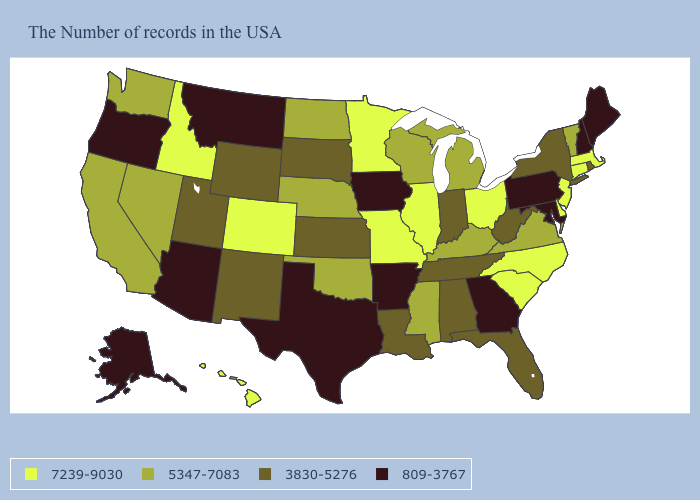What is the value of New Mexico?
Give a very brief answer. 3830-5276. Name the states that have a value in the range 809-3767?
Quick response, please. Maine, New Hampshire, Maryland, Pennsylvania, Georgia, Arkansas, Iowa, Texas, Montana, Arizona, Oregon, Alaska. Name the states that have a value in the range 809-3767?
Answer briefly. Maine, New Hampshire, Maryland, Pennsylvania, Georgia, Arkansas, Iowa, Texas, Montana, Arizona, Oregon, Alaska. Which states hav the highest value in the West?
Quick response, please. Colorado, Idaho, Hawaii. Which states have the lowest value in the USA?
Quick response, please. Maine, New Hampshire, Maryland, Pennsylvania, Georgia, Arkansas, Iowa, Texas, Montana, Arizona, Oregon, Alaska. Name the states that have a value in the range 809-3767?
Short answer required. Maine, New Hampshire, Maryland, Pennsylvania, Georgia, Arkansas, Iowa, Texas, Montana, Arizona, Oregon, Alaska. What is the lowest value in the MidWest?
Concise answer only. 809-3767. Among the states that border Iowa , does Missouri have the highest value?
Write a very short answer. Yes. Which states have the lowest value in the West?
Be succinct. Montana, Arizona, Oregon, Alaska. Name the states that have a value in the range 3830-5276?
Short answer required. Rhode Island, New York, West Virginia, Florida, Indiana, Alabama, Tennessee, Louisiana, Kansas, South Dakota, Wyoming, New Mexico, Utah. Name the states that have a value in the range 809-3767?
Keep it brief. Maine, New Hampshire, Maryland, Pennsylvania, Georgia, Arkansas, Iowa, Texas, Montana, Arizona, Oregon, Alaska. Name the states that have a value in the range 7239-9030?
Answer briefly. Massachusetts, Connecticut, New Jersey, Delaware, North Carolina, South Carolina, Ohio, Illinois, Missouri, Minnesota, Colorado, Idaho, Hawaii. What is the lowest value in the USA?
Quick response, please. 809-3767. Among the states that border Nebraska , does Missouri have the highest value?
Quick response, please. Yes. What is the highest value in the West ?
Concise answer only. 7239-9030. 